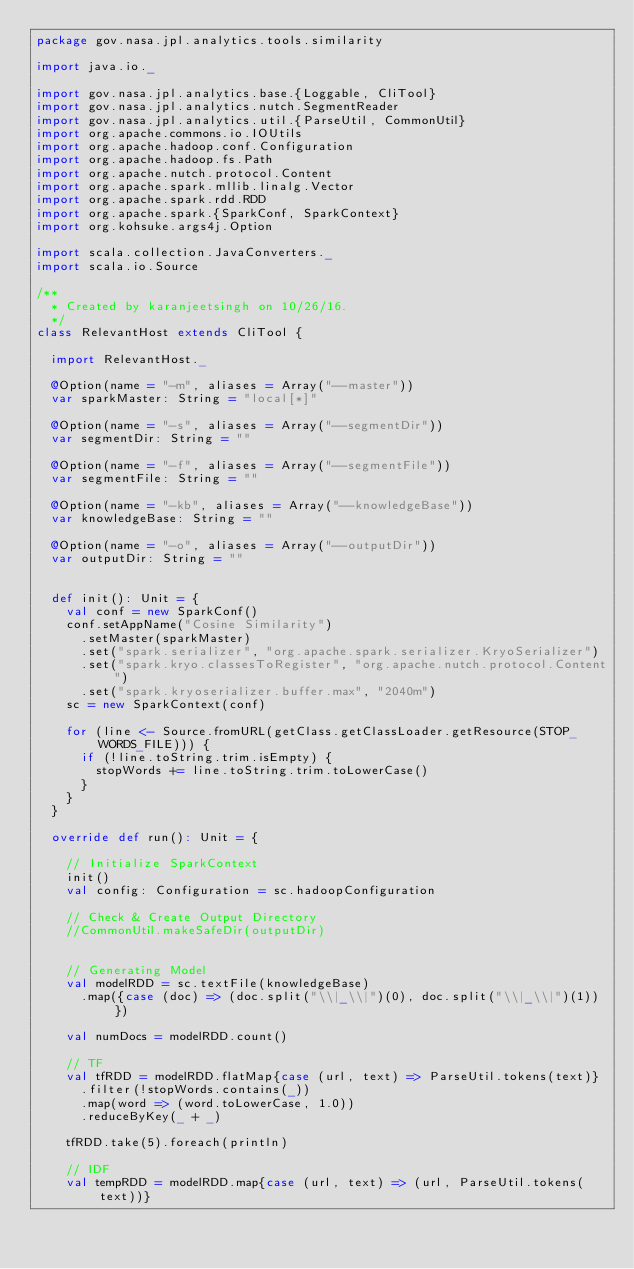<code> <loc_0><loc_0><loc_500><loc_500><_Scala_>package gov.nasa.jpl.analytics.tools.similarity

import java.io._

import gov.nasa.jpl.analytics.base.{Loggable, CliTool}
import gov.nasa.jpl.analytics.nutch.SegmentReader
import gov.nasa.jpl.analytics.util.{ParseUtil, CommonUtil}
import org.apache.commons.io.IOUtils
import org.apache.hadoop.conf.Configuration
import org.apache.hadoop.fs.Path
import org.apache.nutch.protocol.Content
import org.apache.spark.mllib.linalg.Vector
import org.apache.spark.rdd.RDD
import org.apache.spark.{SparkConf, SparkContext}
import org.kohsuke.args4j.Option

import scala.collection.JavaConverters._
import scala.io.Source

/**
  * Created by karanjeetsingh on 10/26/16.
  */
class RelevantHost extends CliTool {

  import RelevantHost._

  @Option(name = "-m", aliases = Array("--master"))
  var sparkMaster: String = "local[*]"

  @Option(name = "-s", aliases = Array("--segmentDir"))
  var segmentDir: String = ""

  @Option(name = "-f", aliases = Array("--segmentFile"))
  var segmentFile: String = ""

  @Option(name = "-kb", aliases = Array("--knowledgeBase"))
  var knowledgeBase: String = ""

  @Option(name = "-o", aliases = Array("--outputDir"))
  var outputDir: String = ""


  def init(): Unit = {
    val conf = new SparkConf()
    conf.setAppName("Cosine Similarity")
      .setMaster(sparkMaster)
      .set("spark.serializer", "org.apache.spark.serializer.KryoSerializer")
      .set("spark.kryo.classesToRegister", "org.apache.nutch.protocol.Content")
      .set("spark.kryoserializer.buffer.max", "2040m")
    sc = new SparkContext(conf)

    for (line <- Source.fromURL(getClass.getClassLoader.getResource(STOP_WORDS_FILE))) {
      if (!line.toString.trim.isEmpty) {
        stopWords += line.toString.trim.toLowerCase()
      }
    }
  }

  override def run(): Unit = {

    // Initialize SparkContext
    init()
    val config: Configuration = sc.hadoopConfiguration

    // Check & Create Output Directory
    //CommonUtil.makeSafeDir(outputDir)


    // Generating Model
    val modelRDD = sc.textFile(knowledgeBase)
      .map({case (doc) => (doc.split("\\|_\\|")(0), doc.split("\\|_\\|")(1))})

    val numDocs = modelRDD.count()

    // TF
    val tfRDD = modelRDD.flatMap{case (url, text) => ParseUtil.tokens(text)}
      .filter(!stopWords.contains(_))
      .map(word => (word.toLowerCase, 1.0))
      .reduceByKey(_ + _)

    tfRDD.take(5).foreach(println)

    // IDF
    val tempRDD = modelRDD.map{case (url, text) => (url, ParseUtil.tokens(text))}</code> 